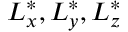<formula> <loc_0><loc_0><loc_500><loc_500>L _ { x } ^ { * } , L _ { y } ^ { * } , L _ { z } ^ { * }</formula> 